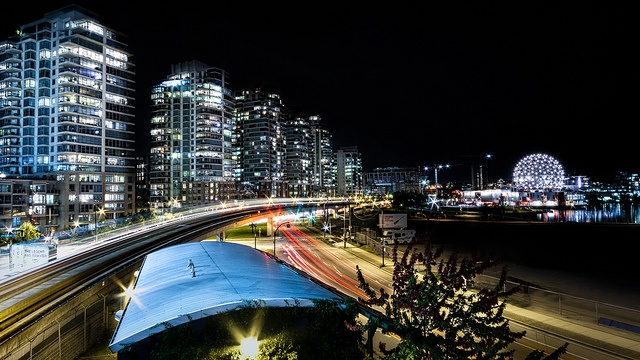Describe the objects in this image and their specific colors. I can see train in black, lightblue, and teal tones and traffic light in black, beige, khaki, and tan tones in this image. 